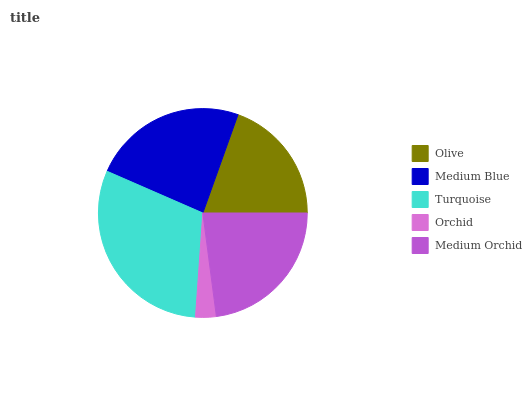Is Orchid the minimum?
Answer yes or no. Yes. Is Turquoise the maximum?
Answer yes or no. Yes. Is Medium Blue the minimum?
Answer yes or no. No. Is Medium Blue the maximum?
Answer yes or no. No. Is Medium Blue greater than Olive?
Answer yes or no. Yes. Is Olive less than Medium Blue?
Answer yes or no. Yes. Is Olive greater than Medium Blue?
Answer yes or no. No. Is Medium Blue less than Olive?
Answer yes or no. No. Is Medium Orchid the high median?
Answer yes or no. Yes. Is Medium Orchid the low median?
Answer yes or no. Yes. Is Olive the high median?
Answer yes or no. No. Is Olive the low median?
Answer yes or no. No. 